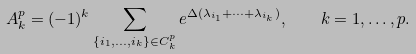<formula> <loc_0><loc_0><loc_500><loc_500>A ^ { p } _ { k } = ( - 1 ) ^ { k } \sum _ { \{ i _ { 1 } , \dots , i _ { k } \} \in C _ { k } ^ { p } } e ^ { \Delta ( \lambda _ { i _ { 1 } } + \cdots + \lambda _ { i _ { k } } ) } , \quad k = 1 , \dots , p .</formula> 